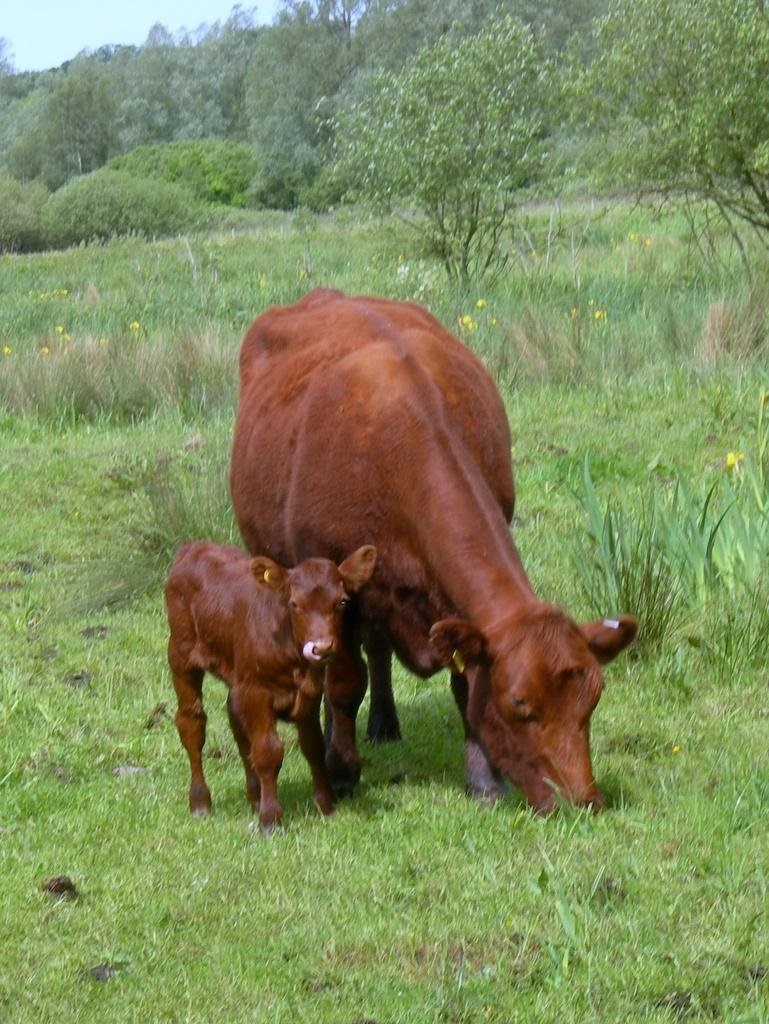What type of animal is in the image? There is a brown cow in the image. What is the cow doing in the image? The cow is eating grass from the ground. Is there a baby cow in the image? Yes, there is a baby cow in the image. What can be seen in the background of the image? There are many trees visible in the background of the image. Can you see the cow smiling in the image? There is no indication of the cow smiling in the image, as animals do not express emotions in the same way as humans. 